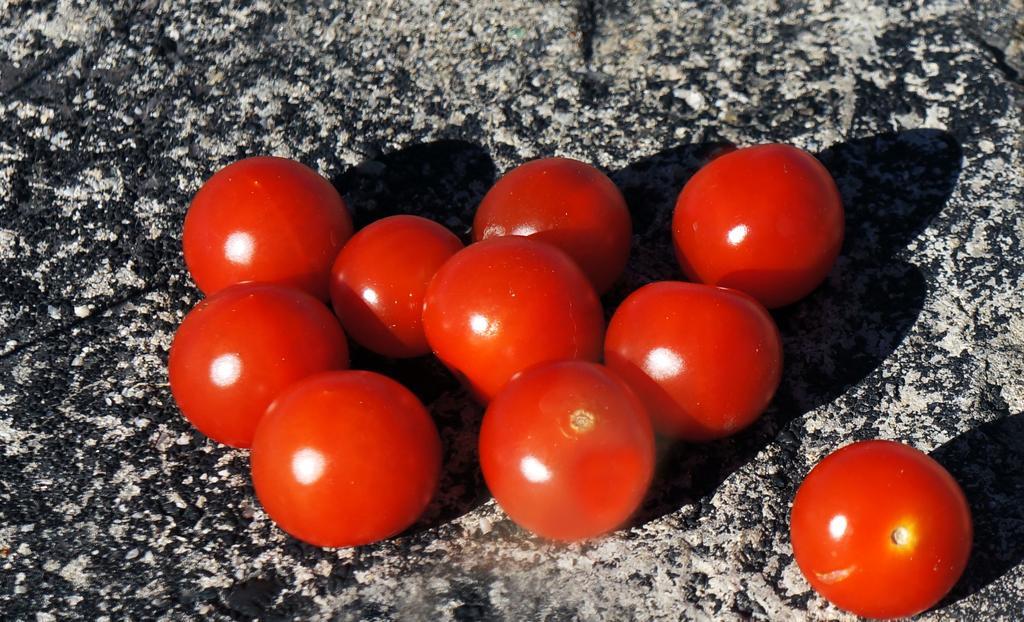Please provide a concise description of this image. In this image I can see there are tomatoes in red color. 